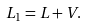Convert formula to latex. <formula><loc_0><loc_0><loc_500><loc_500>L _ { 1 } = L + V .</formula> 